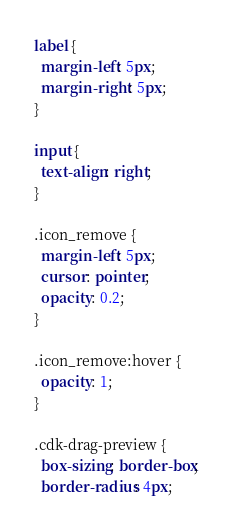Convert code to text. <code><loc_0><loc_0><loc_500><loc_500><_CSS_>label {
  margin-left: 5px;
  margin-right: 5px;
}

input {
  text-align: right;
}

.icon_remove {
  margin-left: 5px;
  cursor: pointer;
  opacity: 0.2;
}

.icon_remove:hover {
  opacity: 1;
}

.cdk-drag-preview {
  box-sizing: border-box;
  border-radius: 4px;</code> 